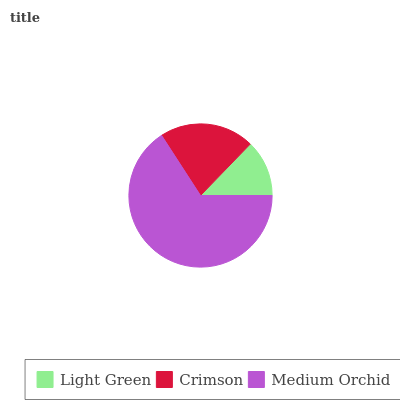Is Light Green the minimum?
Answer yes or no. Yes. Is Medium Orchid the maximum?
Answer yes or no. Yes. Is Crimson the minimum?
Answer yes or no. No. Is Crimson the maximum?
Answer yes or no. No. Is Crimson greater than Light Green?
Answer yes or no. Yes. Is Light Green less than Crimson?
Answer yes or no. Yes. Is Light Green greater than Crimson?
Answer yes or no. No. Is Crimson less than Light Green?
Answer yes or no. No. Is Crimson the high median?
Answer yes or no. Yes. Is Crimson the low median?
Answer yes or no. Yes. Is Light Green the high median?
Answer yes or no. No. Is Medium Orchid the low median?
Answer yes or no. No. 